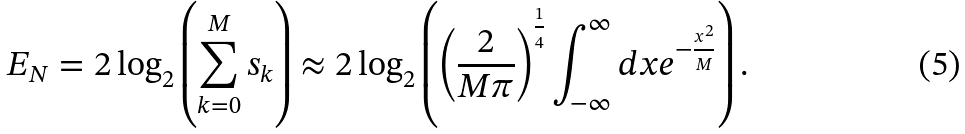<formula> <loc_0><loc_0><loc_500><loc_500>E _ { N } = 2 \log _ { 2 } \left ( \sum _ { k = 0 } ^ { M } { s _ { k } } \right ) \approx 2 \log _ { 2 } \left ( \left ( \frac { 2 } { M \pi } \right ) ^ { \frac { 1 } { 4 } } \int _ { - \infty } ^ { \infty } { d x e ^ { - \frac { x ^ { 2 } } { M } } } \right ) .</formula> 